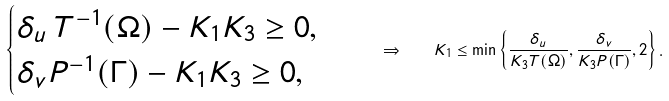<formula> <loc_0><loc_0><loc_500><loc_500>\begin{cases} \delta _ { u } \, T ^ { - 1 } ( \Omega ) - K _ { 1 } K _ { 3 } \geq 0 , \\ \delta _ { v } P ^ { - 1 } ( \Gamma ) - K _ { 1 } K _ { 3 } \geq 0 , \end{cases} \quad \Rightarrow \quad K _ { 1 } \leq \min \left \{ \frac { \delta _ { u } } { K _ { 3 } T ( \Omega ) } , \frac { \delta _ { v } } { K _ { 3 } P ( \Gamma ) } , 2 \right \} .</formula> 